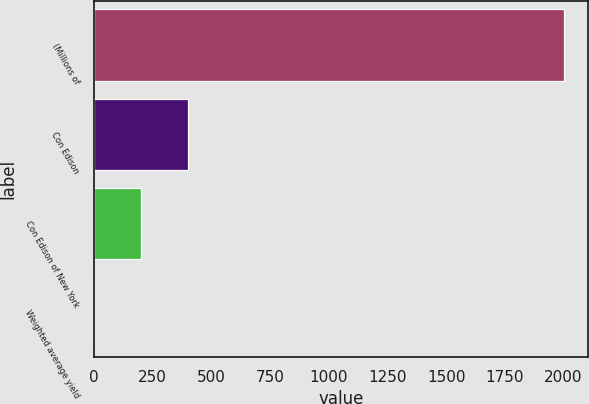Convert chart. <chart><loc_0><loc_0><loc_500><loc_500><bar_chart><fcel>(Millions of<fcel>Con Edison<fcel>Con Edison of New York<fcel>Weighted average yield<nl><fcel>2004<fcel>401.76<fcel>201.48<fcel>1.2<nl></chart> 